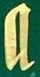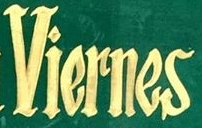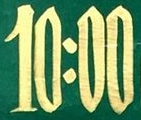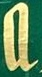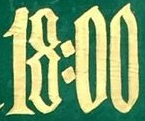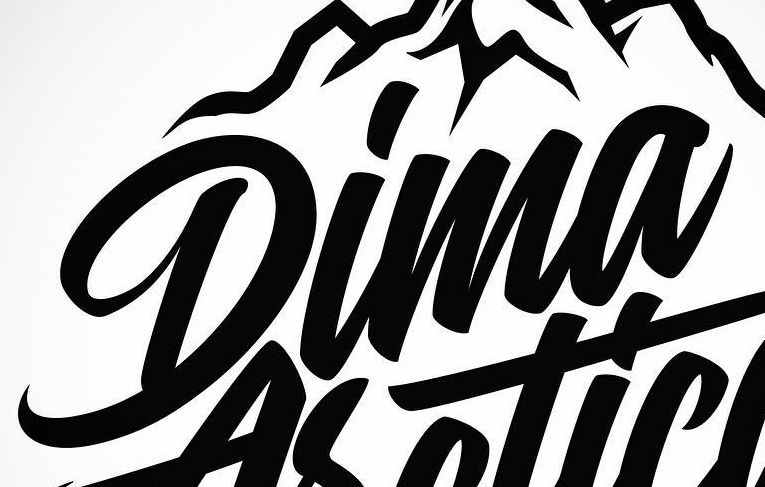Identify the words shown in these images in order, separated by a semicolon. a; Viernes; 10:00; a; 18:00; Dima 